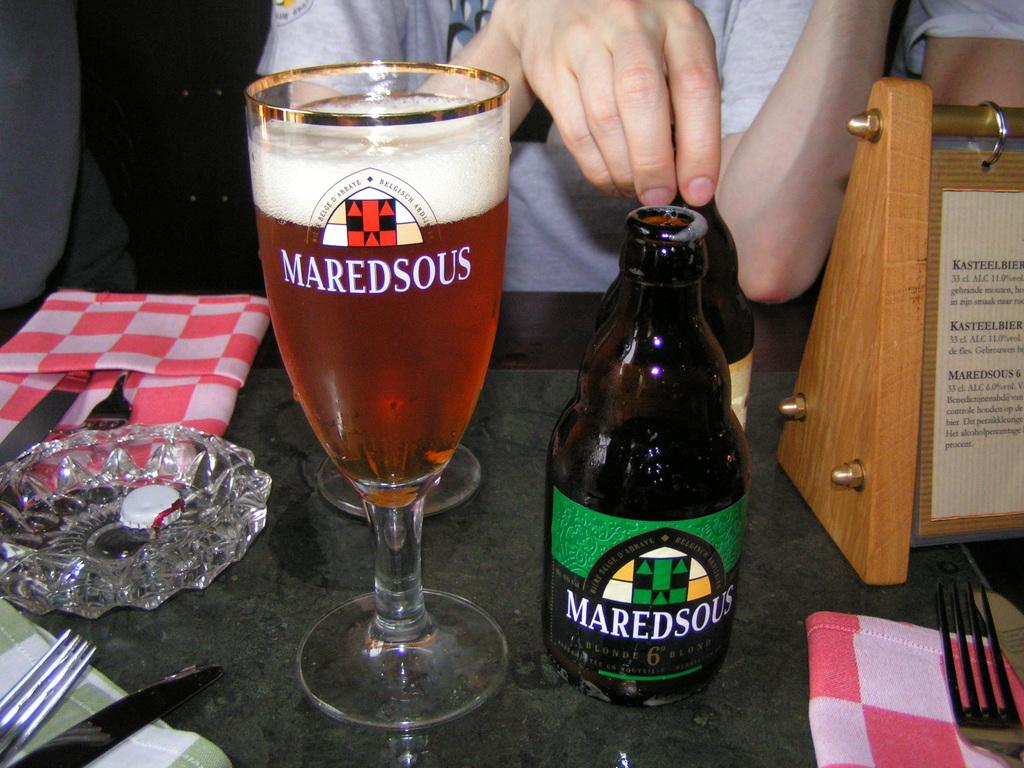<image>
Describe the image concisely. A green mardesous bottle is next to the glass 